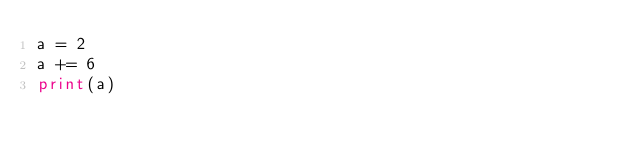Convert code to text. <code><loc_0><loc_0><loc_500><loc_500><_Python_>a = 2
a += 6
print(a)</code> 